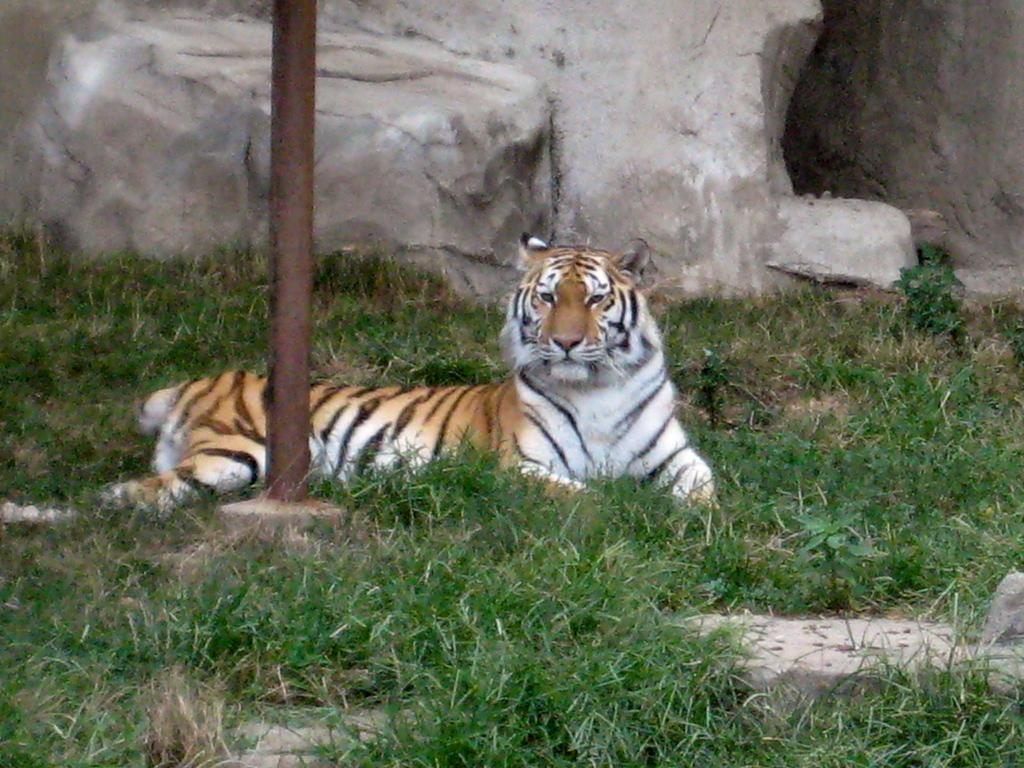What type of animal is in the image? There is a tiger in the image. What colors can be seen on the tiger? The tiger has brown and white coloring. What is the pole in the image used for? The purpose of the pole in the image is not specified, but it could be used for support or as a marker. What type of vegetation is present in the image? There is green grass in the image. What can be seen in the background of the image? There is a rock visible in the background of the image. What type of coat is the tiger wearing in the image? There is no coat present in the image, as the tiger is a wild animal and does not wear clothing. 